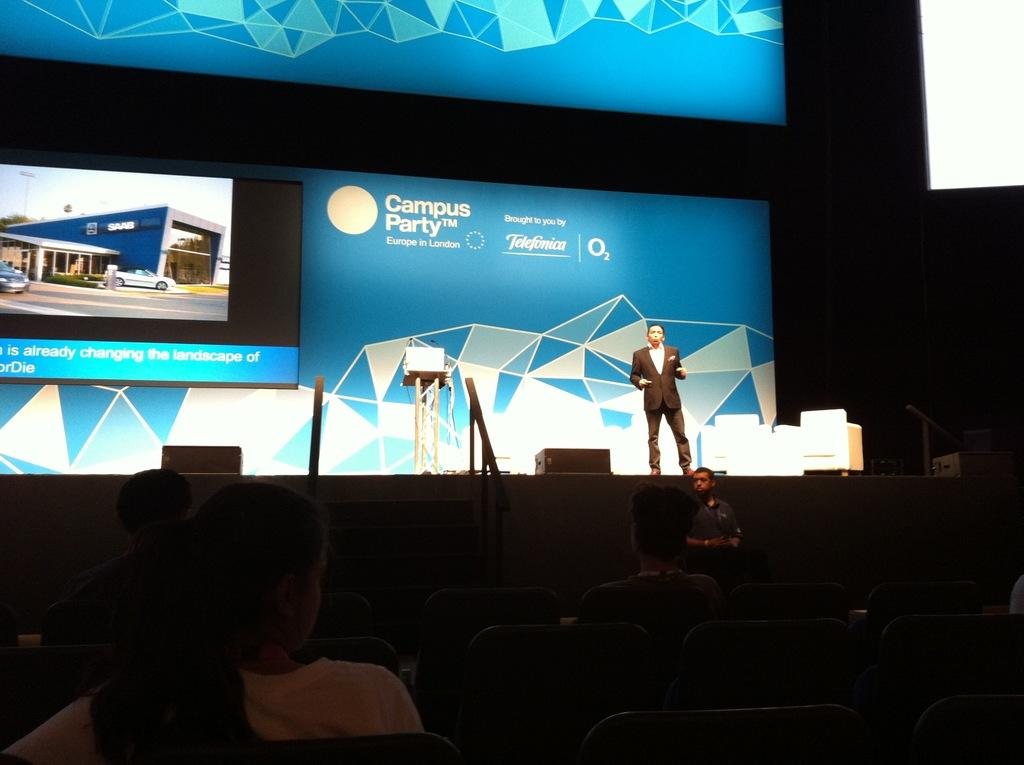What are the people in the image doing? The people in the image are sitting on chairs at the bottom of the image. What is happening in the middle of the image? A man is standing on a stage in the middle of the image. What is the man doing on the stage? The man is speaking. What can be seen on the left side of the image? There is an electronic display on the left side of the image. Can you see any twigs on the stage in the image? There are no twigs present on the stage or anywhere else in the image. What impulse might the man on the stage be feeling while speaking? The provided facts do not give any information about the man's emotions or impulses, so we cannot determine what impulse he might be feeling. 